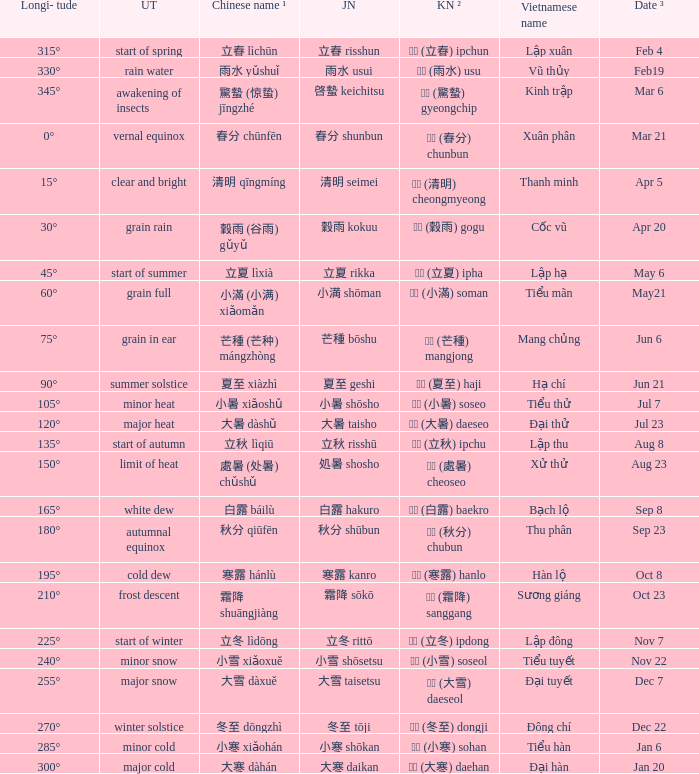When has a Korean name ² of 청명 (清明) cheongmyeong? Apr 5. 